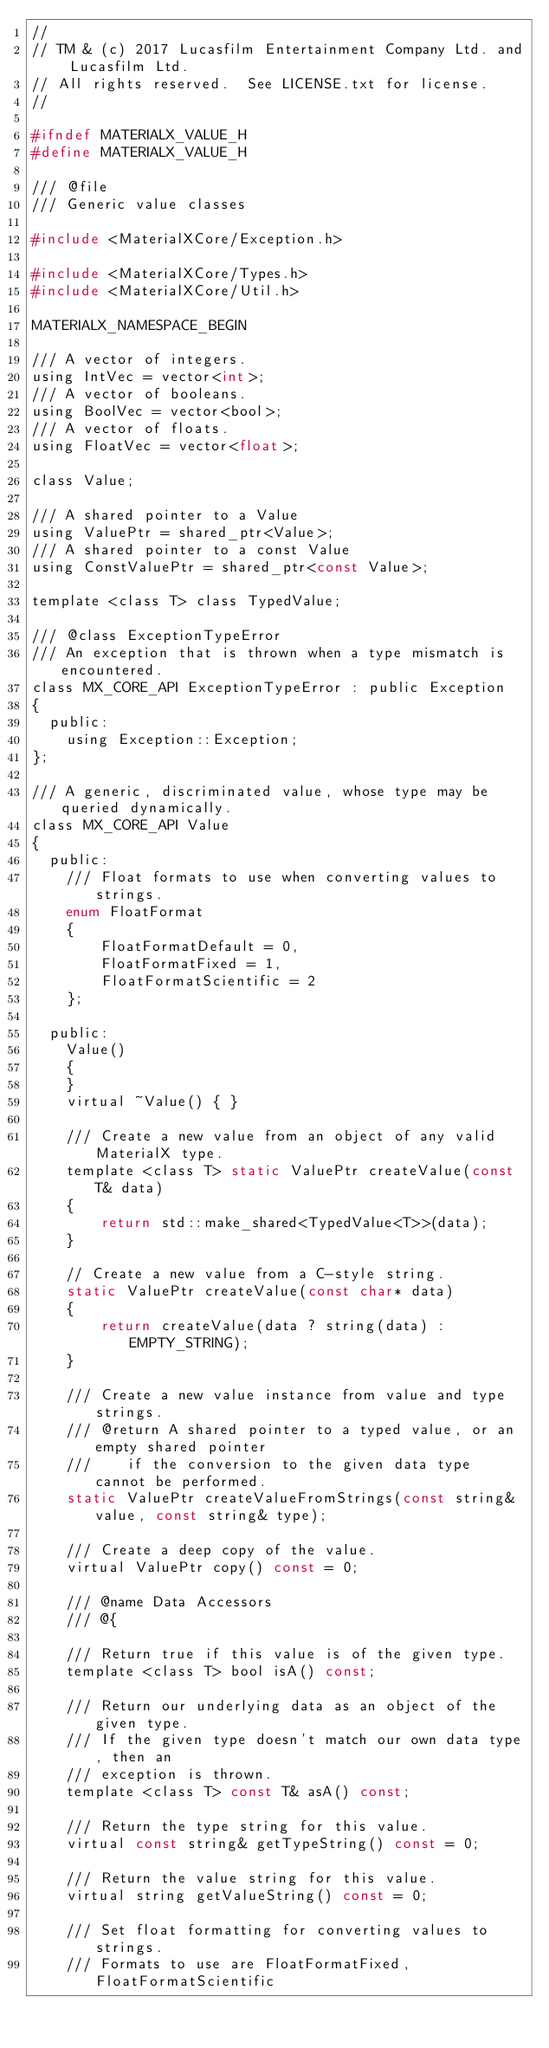Convert code to text. <code><loc_0><loc_0><loc_500><loc_500><_C_>//
// TM & (c) 2017 Lucasfilm Entertainment Company Ltd. and Lucasfilm Ltd.
// All rights reserved.  See LICENSE.txt for license.
//

#ifndef MATERIALX_VALUE_H
#define MATERIALX_VALUE_H

/// @file
/// Generic value classes

#include <MaterialXCore/Exception.h>

#include <MaterialXCore/Types.h>
#include <MaterialXCore/Util.h>

MATERIALX_NAMESPACE_BEGIN

/// A vector of integers.
using IntVec = vector<int>;
/// A vector of booleans.
using BoolVec = vector<bool>;
/// A vector of floats.
using FloatVec = vector<float>;

class Value;

/// A shared pointer to a Value
using ValuePtr = shared_ptr<Value>;
/// A shared pointer to a const Value
using ConstValuePtr = shared_ptr<const Value>;

template <class T> class TypedValue;

/// @class ExceptionTypeError
/// An exception that is thrown when a type mismatch is encountered.
class MX_CORE_API ExceptionTypeError : public Exception
{
  public:
    using Exception::Exception;
};

/// A generic, discriminated value, whose type may be queried dynamically.
class MX_CORE_API Value
{
  public:
    /// Float formats to use when converting values to strings.
    enum FloatFormat
    {
        FloatFormatDefault = 0,
        FloatFormatFixed = 1,
        FloatFormatScientific = 2
    };

  public:
    Value()
    {
    }
    virtual ~Value() { }

    /// Create a new value from an object of any valid MaterialX type.
    template <class T> static ValuePtr createValue(const T& data)
    {
        return std::make_shared<TypedValue<T>>(data);
    }

    // Create a new value from a C-style string.
    static ValuePtr createValue(const char* data)
    {
        return createValue(data ? string(data) : EMPTY_STRING);
    }

    /// Create a new value instance from value and type strings.
    /// @return A shared pointer to a typed value, or an empty shared pointer
    ///    if the conversion to the given data type cannot be performed.
    static ValuePtr createValueFromStrings(const string& value, const string& type);

    /// Create a deep copy of the value.
    virtual ValuePtr copy() const = 0;

    /// @name Data Accessors
    /// @{

    /// Return true if this value is of the given type.
    template <class T> bool isA() const;

    /// Return our underlying data as an object of the given type.
    /// If the given type doesn't match our own data type, then an
    /// exception is thrown.
    template <class T> const T& asA() const;

    /// Return the type string for this value.
    virtual const string& getTypeString() const = 0;

    /// Return the value string for this value.
    virtual string getValueString() const = 0;

    /// Set float formatting for converting values to strings.
    /// Formats to use are FloatFormatFixed, FloatFormatScientific</code> 